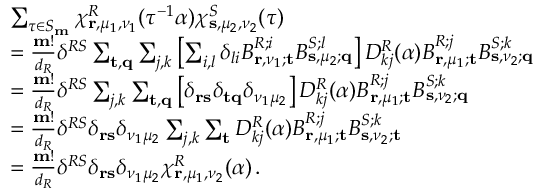Convert formula to latex. <formula><loc_0><loc_0><loc_500><loc_500>\begin{array} { r l } & { \sum _ { \tau \in S _ { m } } \chi _ { r , \mu _ { 1 } , \nu _ { 1 } } ^ { R } ( \tau ^ { - 1 } \alpha ) \chi _ { s , \mu _ { 2 } , \nu _ { 2 } } ^ { S } ( \tau ) } \\ & { = \frac { m ! } { d _ { R } } \delta ^ { R S } \sum _ { t , q } \sum _ { j , k } \left [ \sum _ { i , l } \delta _ { l i } B _ { r , \nu _ { 1 } ; t } ^ { R ; i } B _ { s , \mu _ { 2 } ; q } ^ { S ; l } \right ] D _ { k j } ^ { R } ( \alpha ) B _ { r , \mu _ { 1 } ; t } ^ { R ; j } B _ { s , \nu _ { 2 } ; q } ^ { S ; k } } \\ & { = \frac { m ! } { d _ { R } } \delta ^ { R S } \sum _ { j , k } \sum _ { t , q } \left [ \delta _ { r s } \delta _ { t q } \delta _ { \nu _ { 1 } \mu _ { 2 } } \right ] D _ { k j } ^ { R } ( \alpha ) B _ { r , \mu _ { 1 } ; t } ^ { R ; j } B _ { s , \nu _ { 2 } ; q } ^ { S ; k } } \\ & { = \frac { m ! } { d _ { R } } \delta ^ { R S } \delta _ { r s } \delta _ { \nu _ { 1 } \mu _ { 2 } } \sum _ { j , k } \sum _ { t } D _ { k j } ^ { R } ( \alpha ) B _ { r , \mu _ { 1 } ; t } ^ { R ; j } B _ { s , \nu _ { 2 } ; t } ^ { S ; k } } \\ & { = \frac { m ! } { d _ { R } } \delta ^ { R S } \delta _ { r s } \delta _ { \nu _ { 1 } \mu _ { 2 } } \chi _ { r , \mu _ { 1 } , \nu _ { 2 } } ^ { R } ( \alpha ) \, . } \end{array}</formula> 